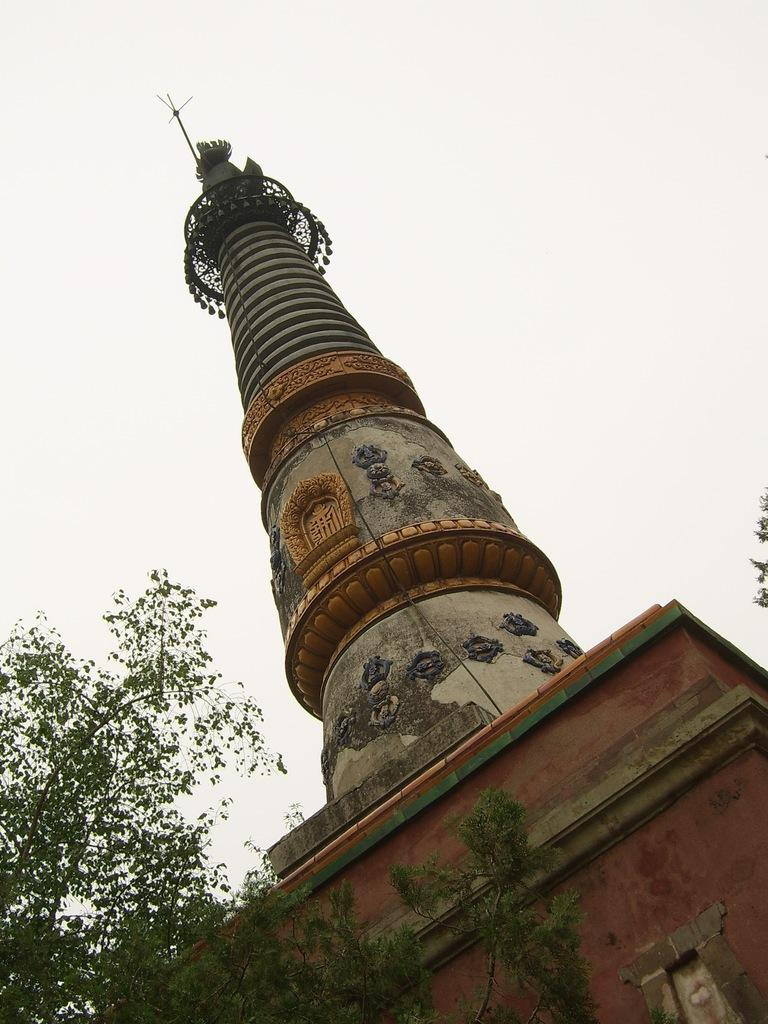What type of structure is present in the image? There is a building in the image. What colors can be seen on the building? The building has brown, grey, and cream colors. What is located to the left of the building? There are trees to the left of the building. What can be seen in the background of the image? The sky is visible in the background of the image. Can you tell me what type of doctor is standing next to the building in the image? There is no doctor present in the image; it only features a building, trees, and the sky. What button is being pushed by the person in the image? There is no person or button visible in the image. 